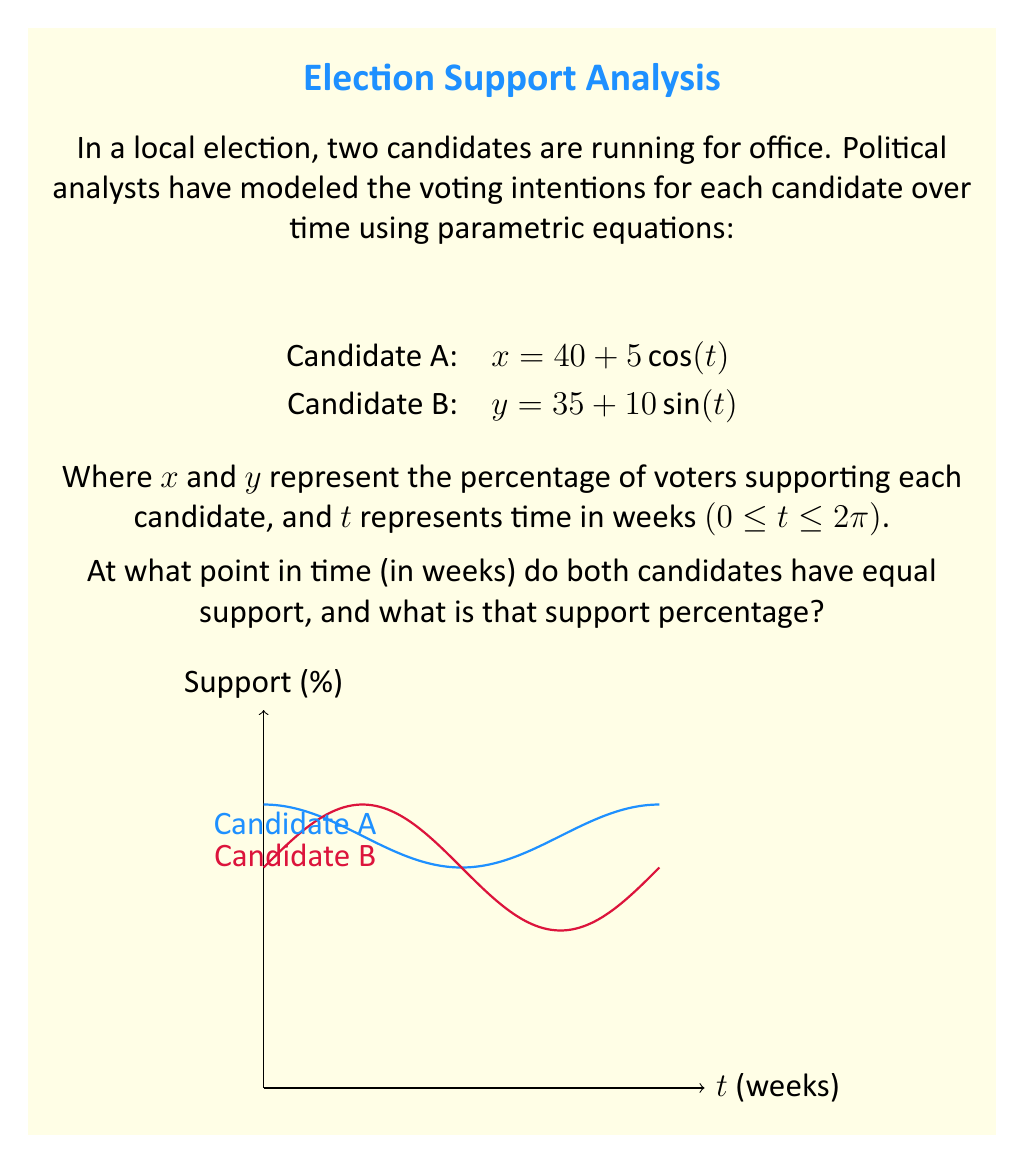Help me with this question. To solve this problem, we need to find the point where the two equations intersect. This occurs when x = y:

1) Set the equations equal to each other:
   $40 + 5\cos(t) = 35 + 10\sin(t)$

2) Rearrange the equation:
   $5\cos(t) - 10\sin(t) = -5$

3) Divide both sides by 5:
   $\cos(t) - 2\sin(t) = -1$

4) This equation can be solved using the substitution method. Let $\sin(t) = u$, then $\cos(t) = \sqrt{1-u^2}$:
   $\sqrt{1-u^2} - 2u = -1$

5) Square both sides:
   $1-u^2 - 4u\sqrt{1-u^2} + 4u^2 = 1$
   $3u^2 - 4u\sqrt{1-u^2} = 0$

6) Factor out $u$:
   $u(3u - 4\sqrt{1-u^2}) = 0$

7) Solve for u:
   $u = 0$ or $3u = 4\sqrt{1-u^2}$
   $9u^2 = 16(1-u^2)$
   $25u^2 = 16$
   $u^2 = \frac{16}{25}$
   $u = \frac{4}{5}$ (we take the positive solution as $\sin(t)$ is positive in the first quadrant)

8) Since $\sin(t) = \frac{4}{5}$, $t = \arcsin(\frac{4}{5}) \approx 0.9273$ radians or about 7.96 weeks

9) To find the support percentage, substitute this value of t into either equation:
   $x = 40 + 5\cos(0.9273) \approx 37.5$

Therefore, both candidates have equal support of approximately 37.5% after about 7.96 weeks.
Answer: $t \approx 7.96$ weeks, support ≈ 37.5% 